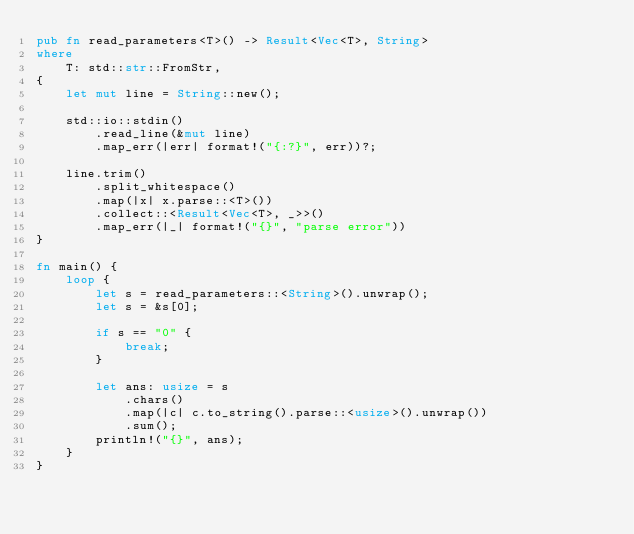Convert code to text. <code><loc_0><loc_0><loc_500><loc_500><_Rust_>pub fn read_parameters<T>() -> Result<Vec<T>, String>
where
    T: std::str::FromStr,
{
    let mut line = String::new();

    std::io::stdin()
        .read_line(&mut line)
        .map_err(|err| format!("{:?}", err))?;

    line.trim()
        .split_whitespace()
        .map(|x| x.parse::<T>())
        .collect::<Result<Vec<T>, _>>()
        .map_err(|_| format!("{}", "parse error"))
}

fn main() {
    loop {
        let s = read_parameters::<String>().unwrap();
        let s = &s[0];

        if s == "0" {
            break;
        }

        let ans: usize = s
            .chars()
            .map(|c| c.to_string().parse::<usize>().unwrap())
            .sum();
        println!("{}", ans);
    }
}

</code> 